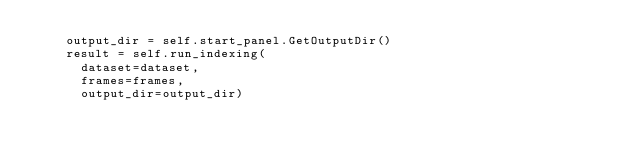<code> <loc_0><loc_0><loc_500><loc_500><_Python_>    output_dir = self.start_panel.GetOutputDir()
    result = self.run_indexing(
      dataset=dataset,
      frames=frames,
      output_dir=output_dir)</code> 